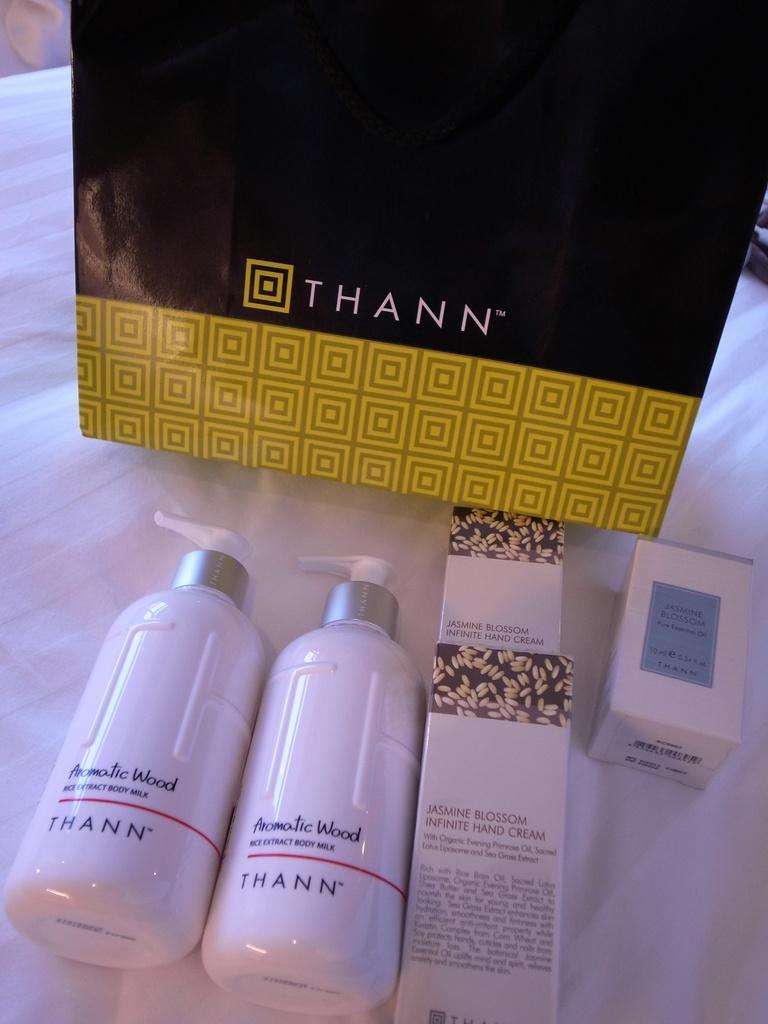What is the name brand of the product?
Provide a short and direct response. Thann. What is the sent of the product?
Ensure brevity in your answer.  Aromatic wood. 